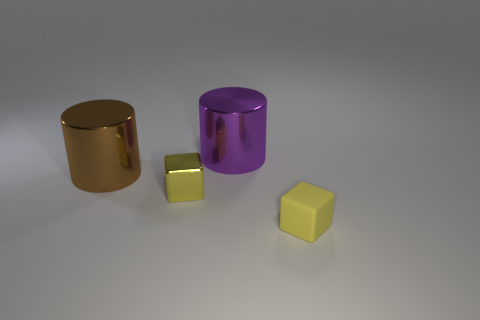Can you infer anything about the lighting source in this scene? The lighting in the scene seems to be diffuse and soft, coming from above. This is indicated by the subtle shadows directly beneath the objects and the soft reflections on their surfaces. There are no harsh shadows, suggesting that the light source may be large or there could be multiple sources creating an even distribution of light. 